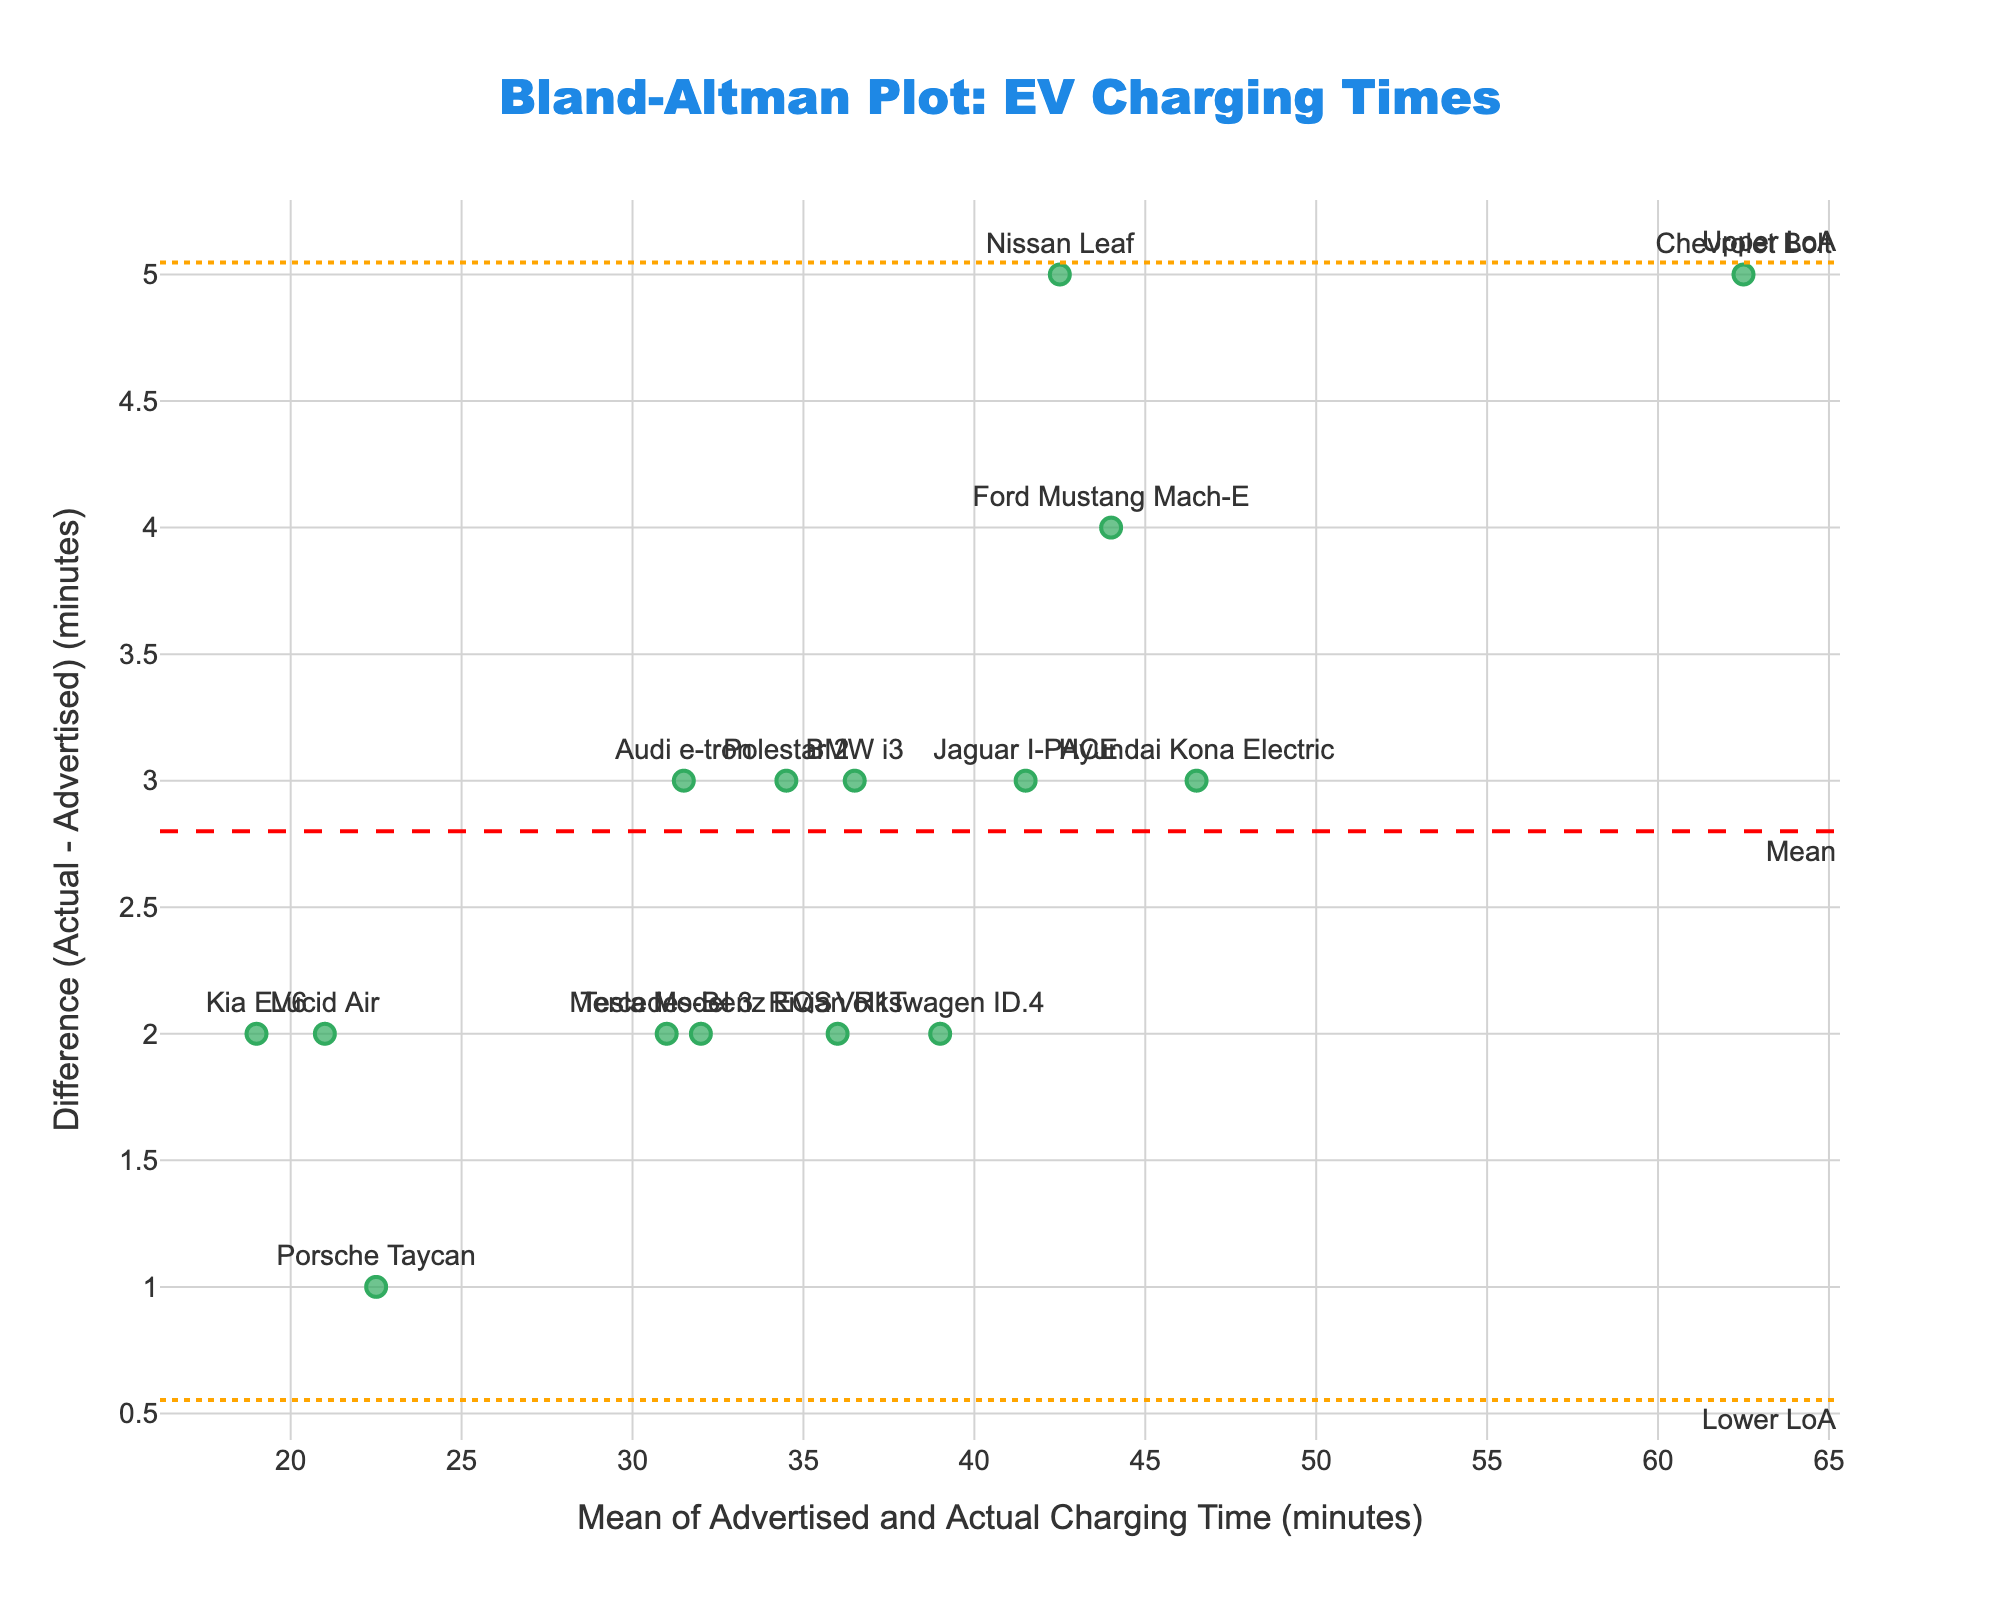What's the mean difference between actual and advertised charging times? To find the mean difference, locate the red dashed line in the figure, which represents the average deviation (difference) between actual and advertised charging times. The y-coordinate of this red dashed line is the mean difference.
Answer: 3 minutes Which model has the largest positive difference between actual and advertised charging times? Look at the vertical axis (difference) and find the point that is highest above zero. Check the label for this point to identify the model.
Answer: Chevrolet Bolt What is the mean of the advertised and actual charging times for the Porsche Taycan according to the plot? Identify the Porsche Taycan on the plot and look at its x-coordinate, which represents the mean of the advertised and actual charging times.
Answer: 22.5 minutes What are the upper and lower limits of agreement? The upper and lower limits of agreement are represented by the dotted orange lines. These lines indicate the range within which most of the differences between actual and advertised charging times fall.
Answer: Upper LoA: 5.62 minutes, Lower LoA: 0.38 minutes How many models have a difference outside the limits of agreement? Count the number of data points (models) that fall above the upper limit or below the lower limit (dotted orange lines).
Answer: 0 models Which model has a mean charging time closest to 30 minutes? Find the point on the x-axis that is closest to 30 minutes and check its corresponding label.
Answer: Tesla Model 3 and Audi e-tron Is there any model where the actual charging time is exactly as advertised? Look for data points that lie exactly on the zero line of the y-axis since they represent zero difference between actual and advertised charging times.
Answer: None Which model has the smallest positive difference between actual and advertised charging times? Identify the point just above the y-axis (difference) and find the model corresponding to the smallest positive difference.
Answer: Porsche Taycan What is the range of differences in charging times for the given models? The range can be calculated by subtracting the smallest difference (lower LoA) from the largest difference (upper LoA). From the dotted orange lines, determine this range.
Answer: 5.24 minutes 